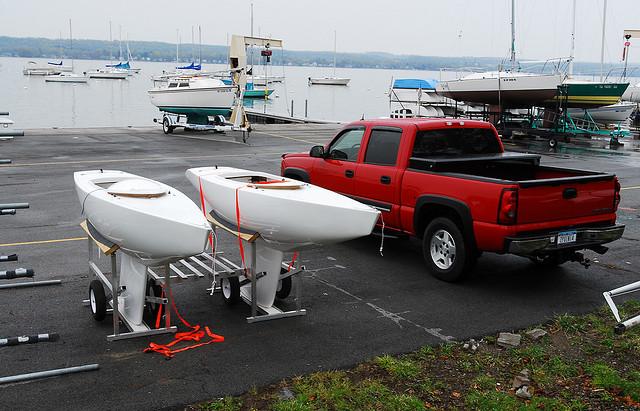Are there street lights in this image?
Be succinct. No. What is next to the truck?
Write a very short answer. Boats. What kind of road is the truck on?
Keep it brief. Parking lot. How many boats are parked next to the red truck?
Short answer required. 2. Is the truck old?
Answer briefly. No. Are the boats on wheels?
Keep it brief. Yes. How many doors does the red truck have?
Keep it brief. 4. How is the weather?
Quick response, please. Cloudy. How are the water conditions?
Keep it brief. Calm. What kind of event is this?
Concise answer only. Boating. 